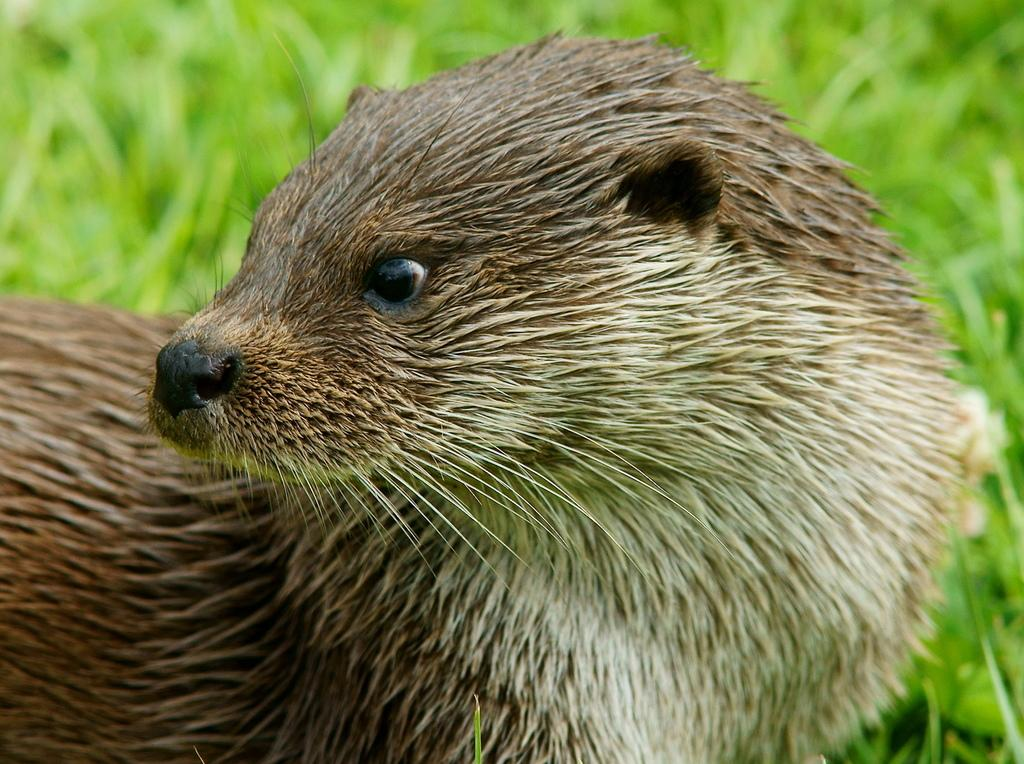What type of animal is in the image? There is an animal in the image, but the specific type cannot be determined from the provided facts. Can you describe the color of the animal? The animal is brown and white in color. What type of environment is depicted in the image? There is grass in the image, which suggests a natural outdoor setting. What degree does the animal's dad have in the image? There is no information about the animal's dad or any degrees in the image. 